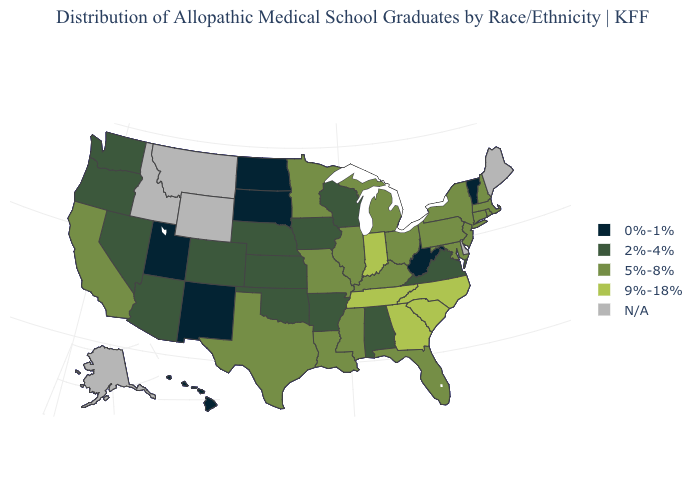What is the value of Alaska?
Write a very short answer. N/A. Among the states that border Maine , which have the lowest value?
Answer briefly. New Hampshire. Name the states that have a value in the range 0%-1%?
Keep it brief. Hawaii, New Mexico, North Dakota, South Dakota, Utah, Vermont, West Virginia. Name the states that have a value in the range 2%-4%?
Write a very short answer. Alabama, Arizona, Arkansas, Colorado, Iowa, Kansas, Nebraska, Nevada, Oklahoma, Oregon, Virginia, Washington, Wisconsin. What is the value of Arizona?
Give a very brief answer. 2%-4%. How many symbols are there in the legend?
Keep it brief. 5. What is the value of Wisconsin?
Write a very short answer. 2%-4%. Name the states that have a value in the range 0%-1%?
Be succinct. Hawaii, New Mexico, North Dakota, South Dakota, Utah, Vermont, West Virginia. What is the lowest value in the USA?
Concise answer only. 0%-1%. Name the states that have a value in the range 0%-1%?
Quick response, please. Hawaii, New Mexico, North Dakota, South Dakota, Utah, Vermont, West Virginia. Name the states that have a value in the range N/A?
Write a very short answer. Alaska, Delaware, Idaho, Maine, Montana, Wyoming. Name the states that have a value in the range 9%-18%?
Keep it brief. Georgia, Indiana, North Carolina, South Carolina, Tennessee. Name the states that have a value in the range 2%-4%?
Short answer required. Alabama, Arizona, Arkansas, Colorado, Iowa, Kansas, Nebraska, Nevada, Oklahoma, Oregon, Virginia, Washington, Wisconsin. 